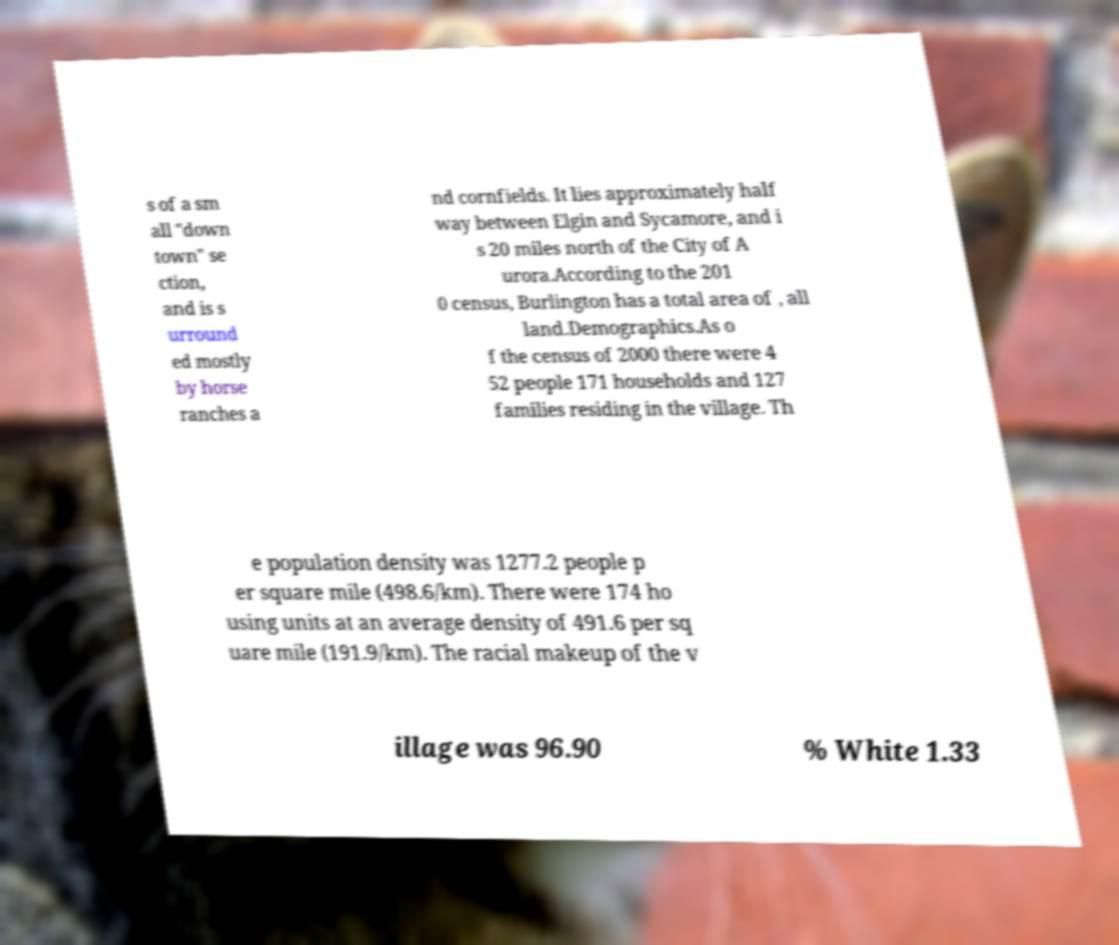For documentation purposes, I need the text within this image transcribed. Could you provide that? s of a sm all "down town" se ction, and is s urround ed mostly by horse ranches a nd cornfields. It lies approximately half way between Elgin and Sycamore, and i s 20 miles north of the City of A urora.According to the 201 0 census, Burlington has a total area of , all land.Demographics.As o f the census of 2000 there were 4 52 people 171 households and 127 families residing in the village. Th e population density was 1277.2 people p er square mile (498.6/km). There were 174 ho using units at an average density of 491.6 per sq uare mile (191.9/km). The racial makeup of the v illage was 96.90 % White 1.33 